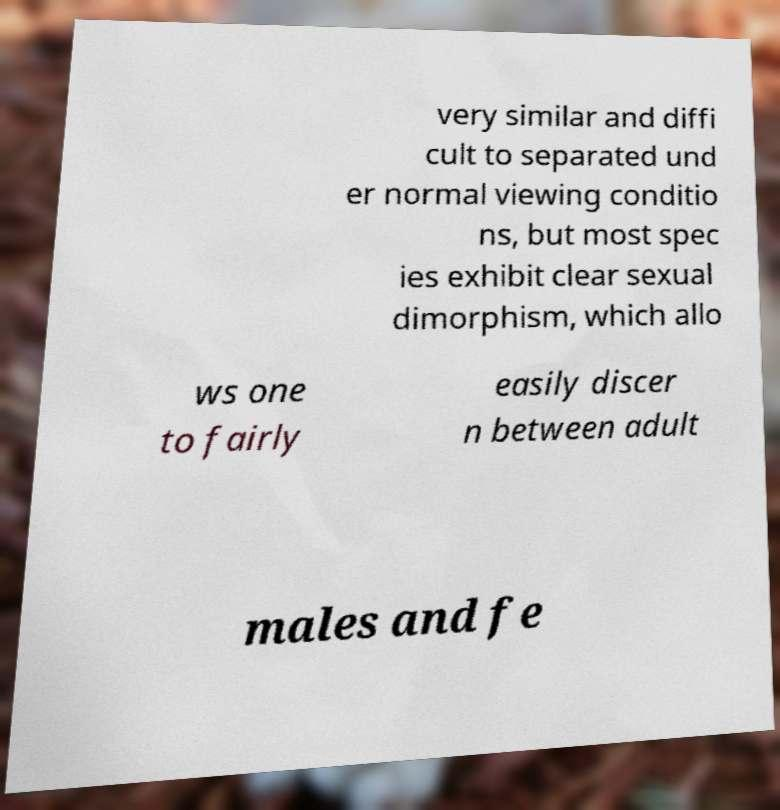Can you accurately transcribe the text from the provided image for me? very similar and diffi cult to separated und er normal viewing conditio ns, but most spec ies exhibit clear sexual dimorphism, which allo ws one to fairly easily discer n between adult males and fe 